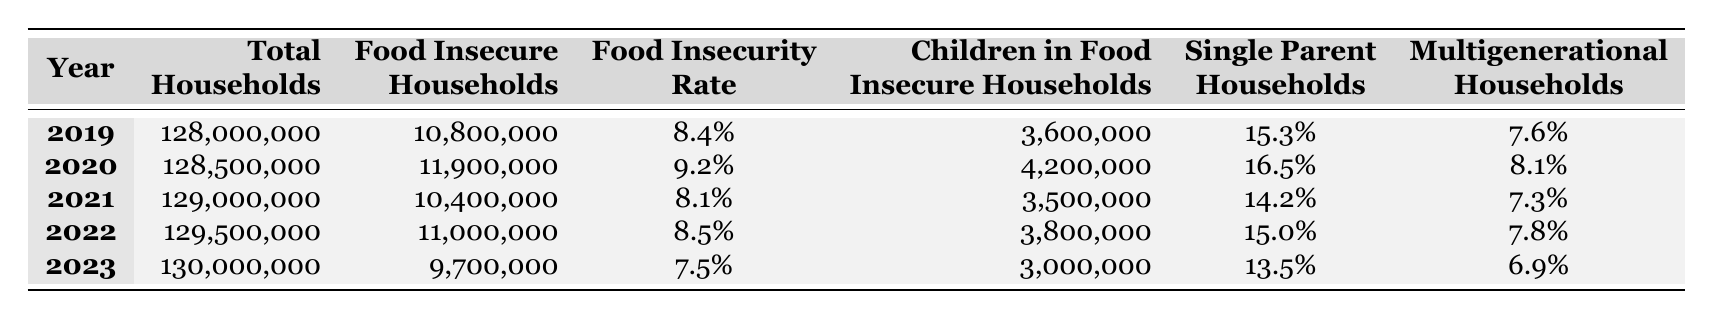What was the food insecurity rate in 2022? In the table's row for 2022, the food insecurity rate is listed under the "Food Insecurity Rate" column, which shows "8.5%".
Answer: 8.5% How many food insecure households were reported in 2020? The number of food insecure households for 2020 can be found in the row corresponding to that year in the "Food Insecure Households" column, which states 11,900,000.
Answer: 11,900,000 What is the average food insecurity rate over the five years from 2019 to 2023? To find the average, sum the food insecurity rates for each year (8.4 + 9.2 + 8.1 + 8.5 + 7.5 = 41.7) and divide by 5, giving an average of 41.7 / 5 = 8.34%.
Answer: 8.34% Was the food insecurity rate higher in 2020 than in 2021? Comparing the rates for 2020 (9.2%) and 2021 (8.1%) shows that 9.2% is greater than 8.1%, thus confirming that the food insecurity rate was indeed higher in 2020.
Answer: Yes How many children lived in food insecure households in 2023 compared to 2022? The table shows 3,000,000 children in food insecure households in 2023 (from that row) and 3,800,000 in 2022. The difference is 3,800,000 - 3,000,000 = 800,000 fewer children in 2023.
Answer: 800,000 fewer What percentage of single-parent households were food insecure in 2019? The percentage for single-parent households in 2019 is listed as 15.3% in that year's row under the "Single Parent Households" column.
Answer: 15.3% In which year was the total number of food insecure households the lowest? Looking through the "Food Insecure Households" column, the lowest value is 9,700,000 in 2023, which indicates that this year recorded the fewest food insecure households.
Answer: 2023 How did the number of multigenerational households change from 2020 to 2023? For 2020, the percentage of multigenerational households is 8.1%, while in 2023 it is 6.9%. The change in percentage is 8.1% - 6.9% = 1.2%, showing a decline.
Answer: Declined by 1.2% What was the total increase in food insecure households from 2019 to 2020? The number of food insecure households increased from 10,800,000 in 2019 to 11,900,000 in 2020. The increase is calculated by subtracting: 11,900,000 - 10,800,000 = 1,100,000.
Answer: 1,100,000 Did the total number of households increase or decrease from 2022 to 2023? In 2022, the total number of households was 129,500,000 and in 2023 it increased to 130,000,000. Thus, the total number of households increased from 2022 to 2023.
Answer: Increased 